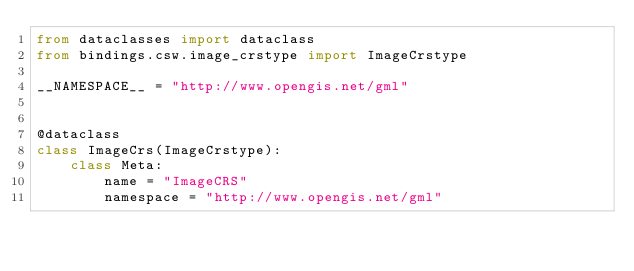Convert code to text. <code><loc_0><loc_0><loc_500><loc_500><_Python_>from dataclasses import dataclass
from bindings.csw.image_crstype import ImageCrstype

__NAMESPACE__ = "http://www.opengis.net/gml"


@dataclass
class ImageCrs(ImageCrstype):
    class Meta:
        name = "ImageCRS"
        namespace = "http://www.opengis.net/gml"
</code> 